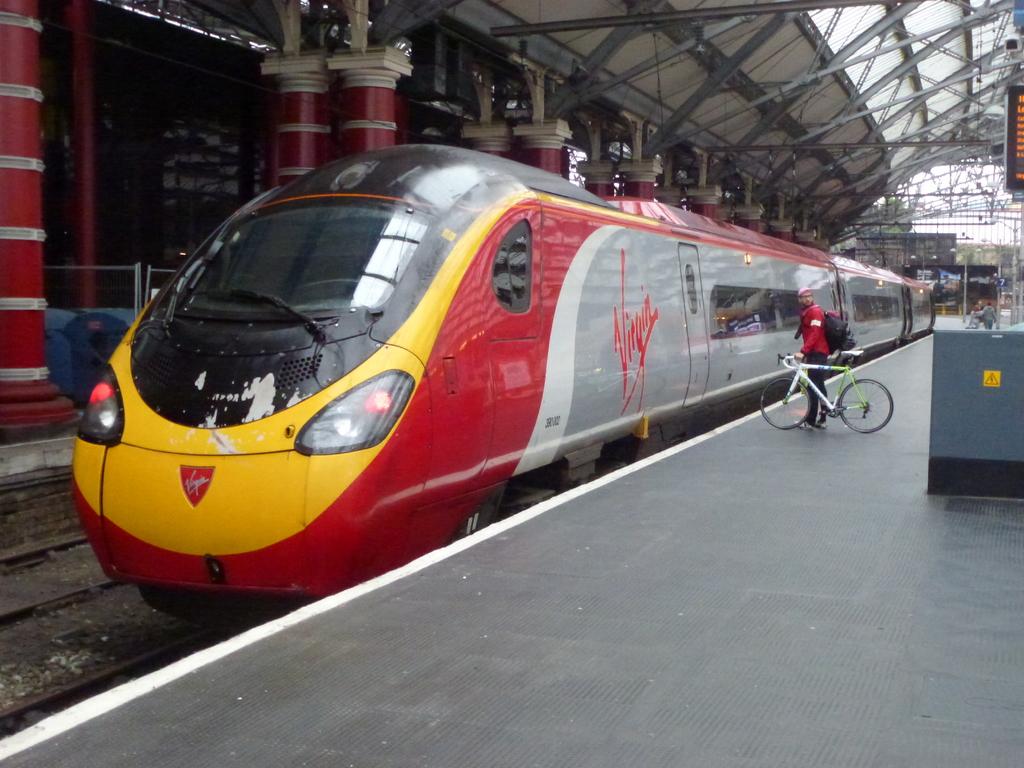Is that train sponsored by virgin?
Give a very brief answer. Yes. 